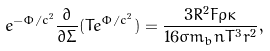<formula> <loc_0><loc_0><loc_500><loc_500>e ^ { - \Phi / c ^ { 2 } } \frac { \partial } { { \partial } \Sigma } ( T e ^ { \Phi / c ^ { 2 } } ) = \frac { 3 R ^ { 2 } F \rho \kappa } { 1 6 \sigma m _ { b } n T ^ { 3 } r ^ { 2 } } ,</formula> 